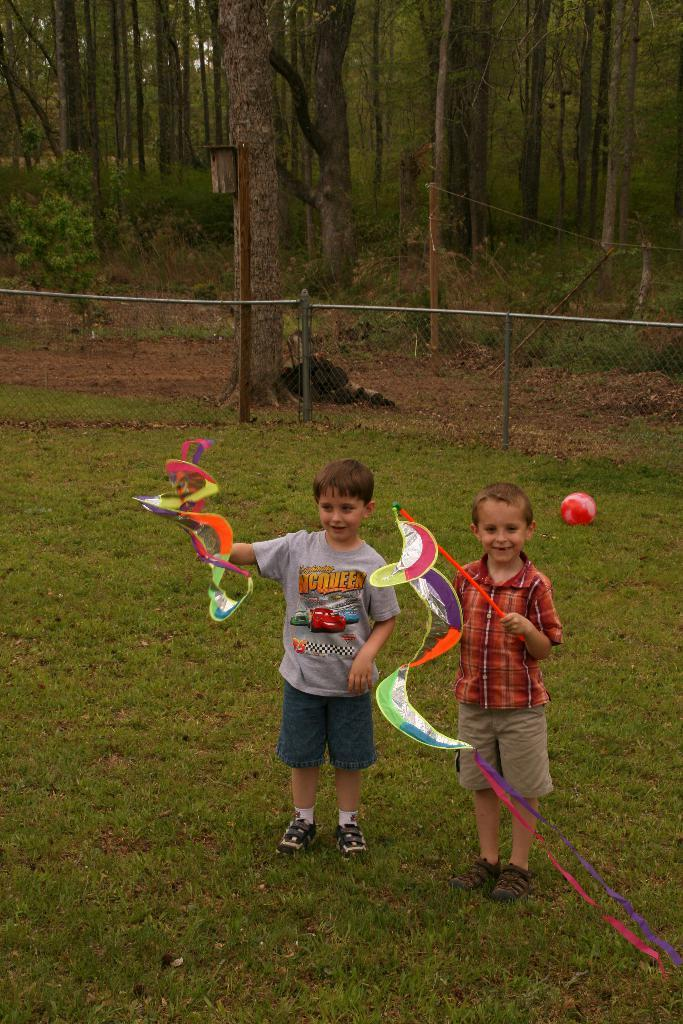How many kids are in the image? There are two kids in the image. What are the kids doing in the image? The kids are standing and holding toys. What is the ground made of in the image? There is grass on the ground in the image. What is the fence used for in the image? The fence is visible in the image, but its purpose is not specified. What type of vegetation is present in the image? There are trees in the image. What type of guitar can be seen in the store in the image? There is no guitar or store present in the image. What country is depicted in the image? The image does not depict a specific country; it only shows two kids, toys, grass, a fence, and trees. 